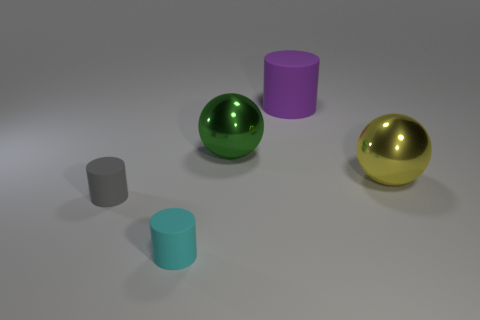Is there a tiny cylinder that has the same material as the gray thing?
Ensure brevity in your answer.  Yes. The other metallic object that is the same shape as the green metallic thing is what color?
Give a very brief answer. Yellow. Are there fewer large green metal spheres that are in front of the gray object than tiny rubber cylinders that are behind the purple cylinder?
Keep it short and to the point. No. What number of other things are there of the same shape as the big purple matte object?
Your answer should be compact. 2. Is the number of large yellow metal objects that are in front of the big yellow object less than the number of large green metallic spheres?
Offer a very short reply. Yes. What is the sphere left of the big yellow shiny thing made of?
Make the answer very short. Metal. How many other objects are the same size as the cyan thing?
Your response must be concise. 1. Are there fewer large metal spheres than large green things?
Your response must be concise. No. The cyan rubber object has what shape?
Make the answer very short. Cylinder. There is a tiny cylinder that is behind the cyan object; is it the same color as the large rubber cylinder?
Provide a succinct answer. No. 